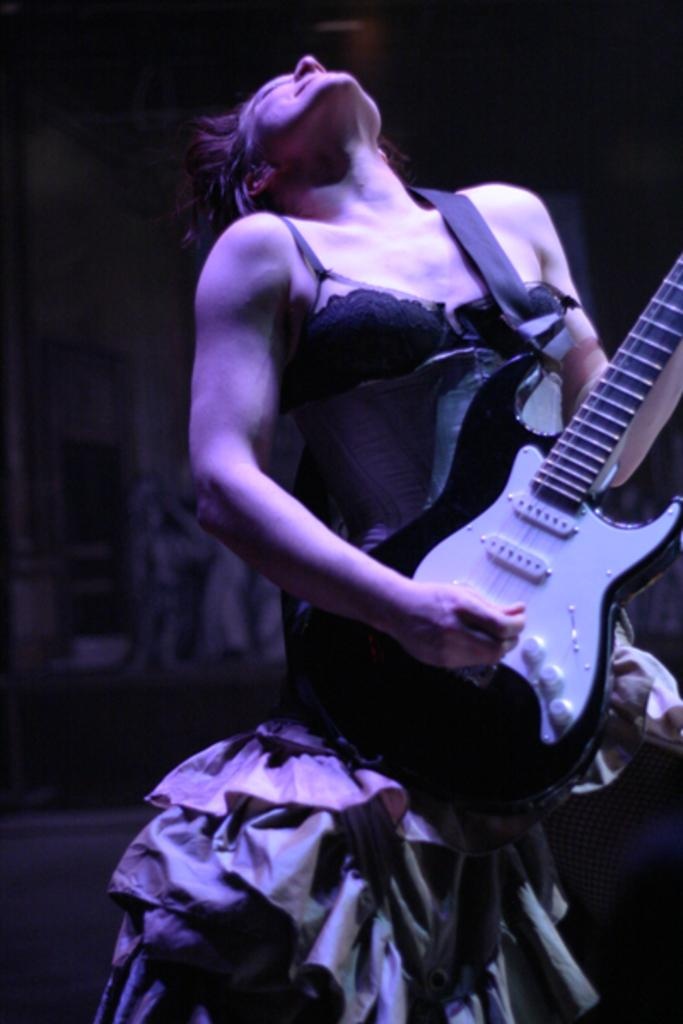Who is the main subject in the image? There is a woman in the image. What is the woman doing in the image? The woman is standing and playing a guitar. What direction is the woman looking in the image? The woman is looking upwards. What can be seen in the background of the image? There is a wall in the background of the image. What type of lunch is the woman eating in the image? There is no lunch present in the image; the woman is playing a guitar. Can you tell me how many knives are visible in the image? There are no knives visible in the image. 